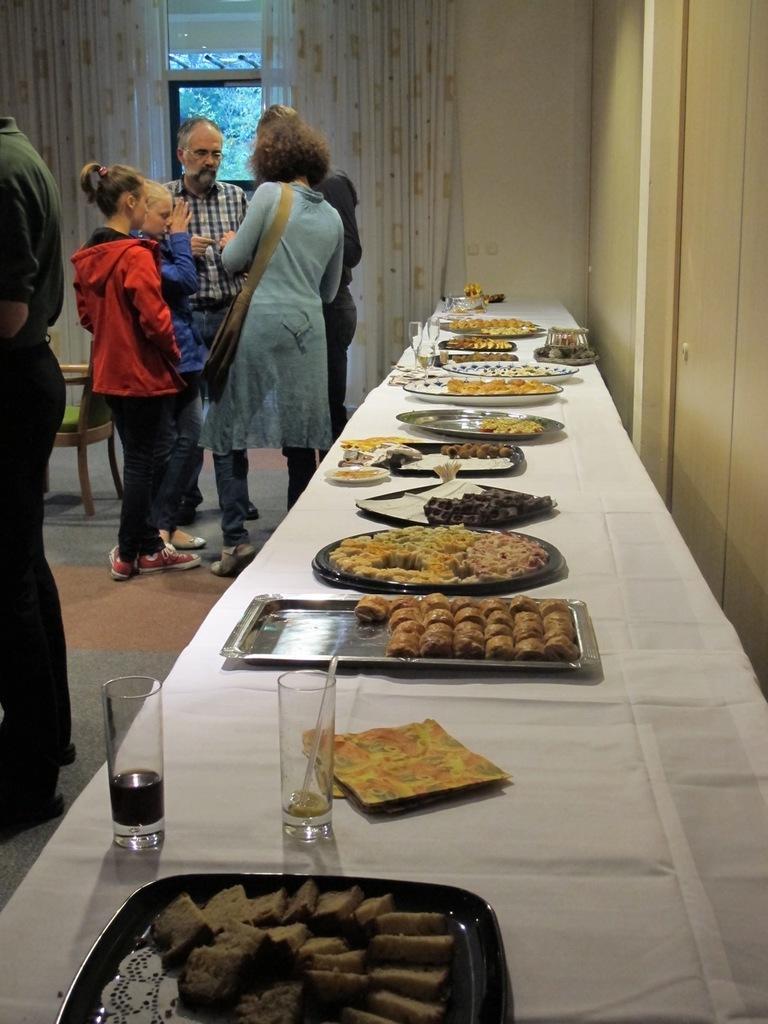Could you give a brief overview of what you see in this image? In this picture there is a group of person who are standing near to the table. On the table I can see the plates, water glass, coke glass, rice, sweets and other food items. Beside this group I can see the window and chairs. Through the window I can see the trees. On the left there is a man who is wearing t-shirt, short and shoes. 